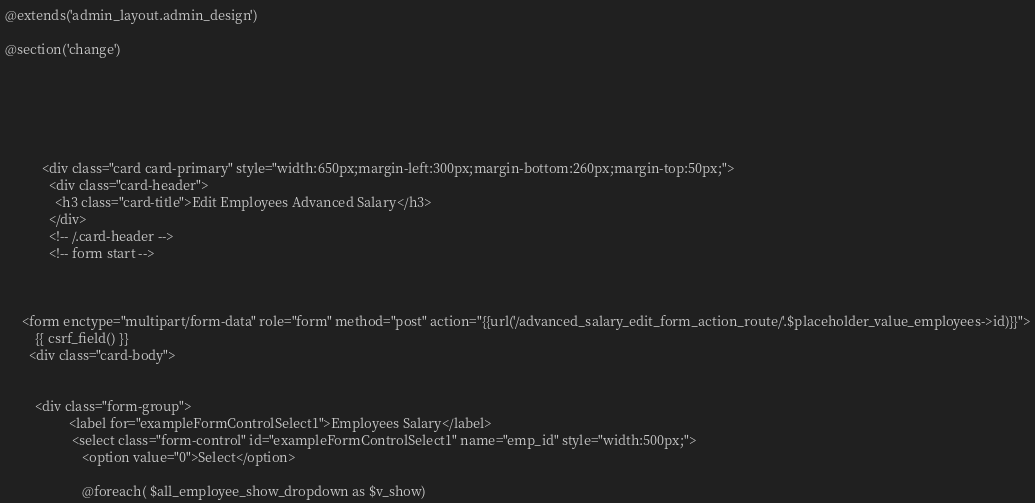Convert code to text. <code><loc_0><loc_0><loc_500><loc_500><_PHP_>@extends('admin_layout.admin_design')

@section('change')






           <div class="card card-primary" style="width:650px;margin-left:300px;margin-bottom:260px;margin-top:50px;">
             <div class="card-header">
               <h3 class="card-title">Edit Employees Advanced Salary</h3>
             </div>
             <!-- /.card-header -->
             <!-- form start -->



     <form enctype="multipart/form-data" role="form" method="post" action="{{url('/advanced_salary_edit_form_action_route/'.$placeholder_value_employees->id)}}">
         {{ csrf_field() }}
       <div class="card-body">


         <div class="form-group">
                   <label for="exampleFormControlSelect1">Employees Salary</label>
                    <select class="form-control" id="exampleFormControlSelect1" name="emp_id" style="width:500px;">
                       <option value="0">Select</option>

                       @foreach( $all_employee_show_dropdown as $v_show)</code> 